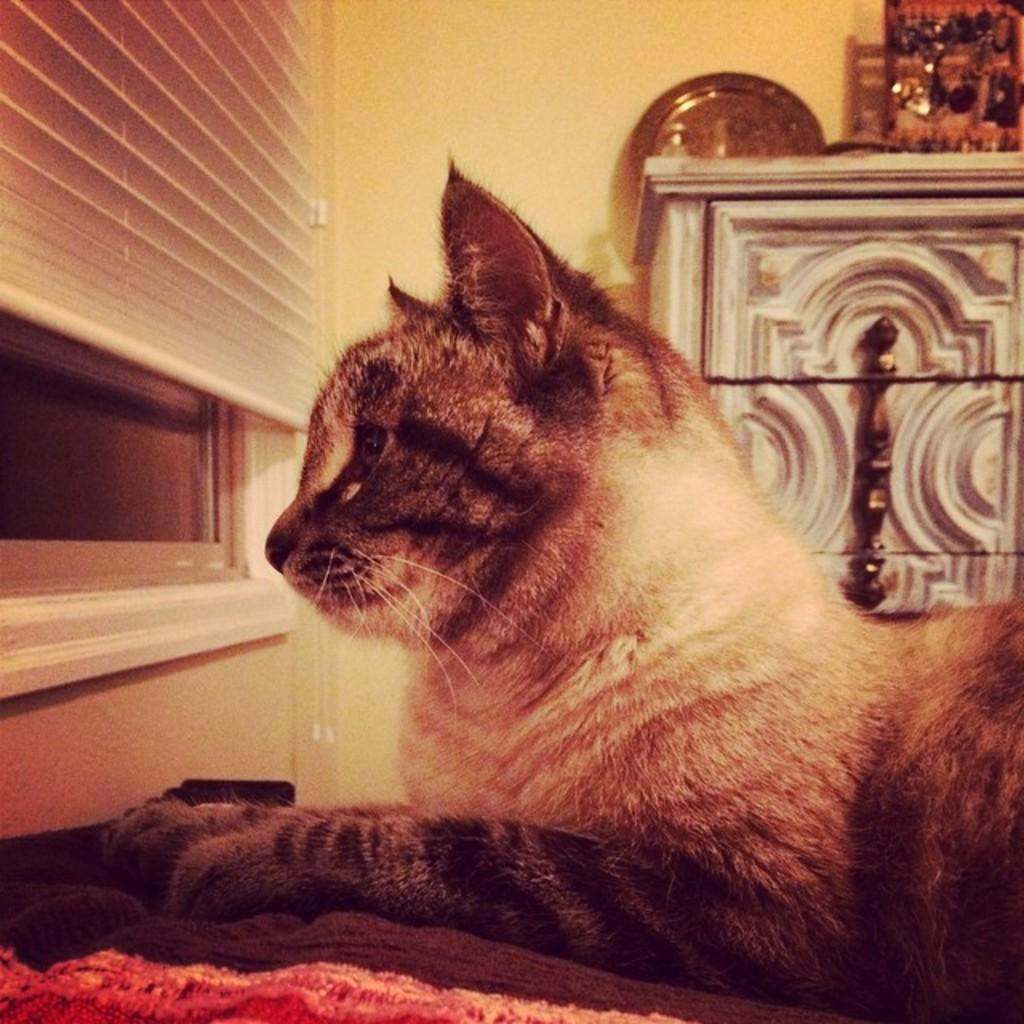What animal is present in the image? There is a cat in the image. What is the cat sitting on? The cat is sitting on clothes. What can be seen in the background of the image? There is a window with blinds and a wall in the background of the image. Are there any other objects visible in the background? Yes, there are other objects visible in the background of the image. What type of ring can be seen on the cat's tail in the image? There is no ring present on the cat's tail in the image. What level of detail can be observed on the cat's fur in the image? The level of detail on the cat's fur cannot be determined from the image, as the resolution or quality of the image is not specified. 